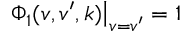Convert formula to latex. <formula><loc_0><loc_0><loc_500><loc_500>\Phi _ { 1 } ( v , v ^ { \prime } , k ) \Big | _ { v = v ^ { \prime } } = 1</formula> 